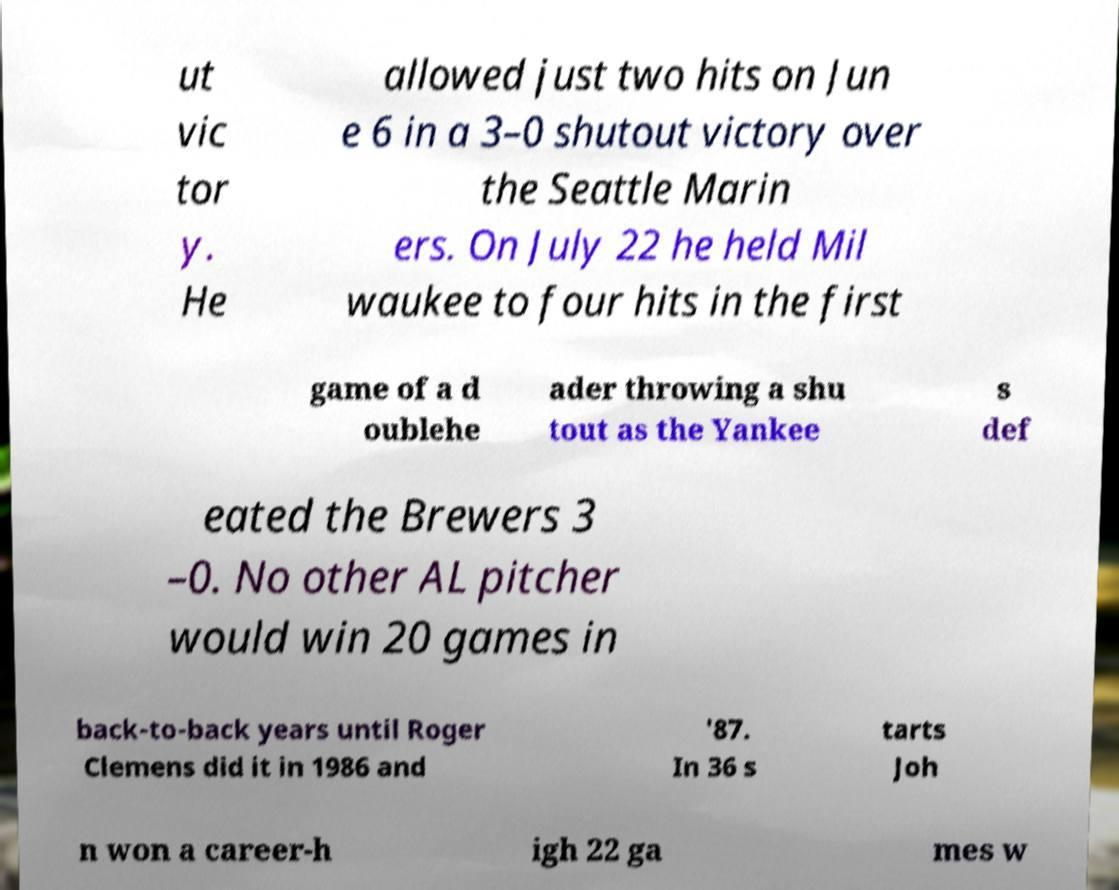Could you assist in decoding the text presented in this image and type it out clearly? ut vic tor y. He allowed just two hits on Jun e 6 in a 3–0 shutout victory over the Seattle Marin ers. On July 22 he held Mil waukee to four hits in the first game of a d oublehe ader throwing a shu tout as the Yankee s def eated the Brewers 3 –0. No other AL pitcher would win 20 games in back-to-back years until Roger Clemens did it in 1986 and '87. In 36 s tarts Joh n won a career-h igh 22 ga mes w 